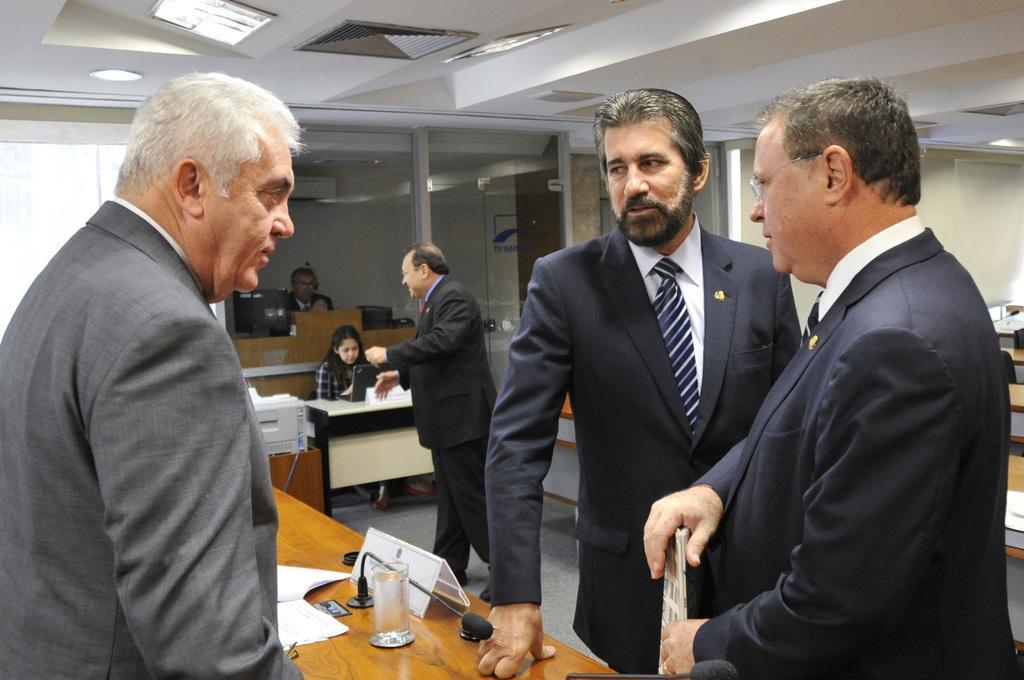Can you describe this image briefly? This image is taken from inside, in this image we can see there are a few people standing, in between them there is a table with some papers, glass, mic and name plate on top of it, behind them there is a person standing and a girl sitting on the chair, in front of her there is a table with monitor, beside her there is an object placed on the other table, behind the girl there is another person sitting on the chair, in front of him there is a table with monitors. In the background there is a wall and at the top of the image there is a ceiling with lights. 